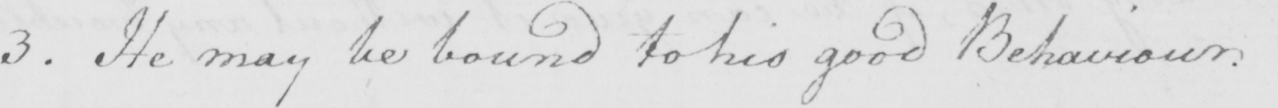What text is written in this handwritten line? 3 . He may be bound to his good Behaviour . 